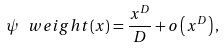Convert formula to latex. <formula><loc_0><loc_0><loc_500><loc_500>\psi _ { \ } w e i g h t ( x ) = \frac { x ^ { D } } { D } + o \left ( x ^ { D } \right ) ,</formula> 